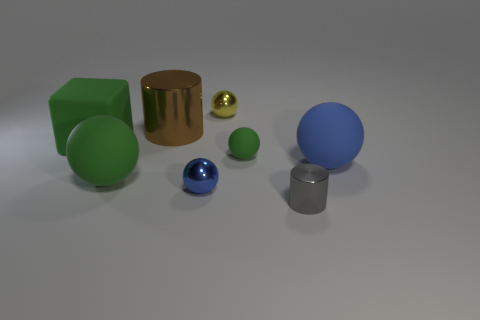How many objects are there in the image, and can you describe their shapes and colors? In the image, there are six objects incorporating a variety of shapes and colors. Starting from the left, there's a large green cube, a gold cylindrical shape, a small golden sphere, a large blue sphere, a smaller blue sphere, and a silver cuboid. Each has a distinct color and a visibly different texture. Which objects appear to have a reflective surface? The gold cylinder and the small golden sphere both have reflective surfaces, evident by the way they catch the light and seem to mirror their environment. The silver cuboid also has a somewhat reflective surface, although it is less polished than the golden objects. 